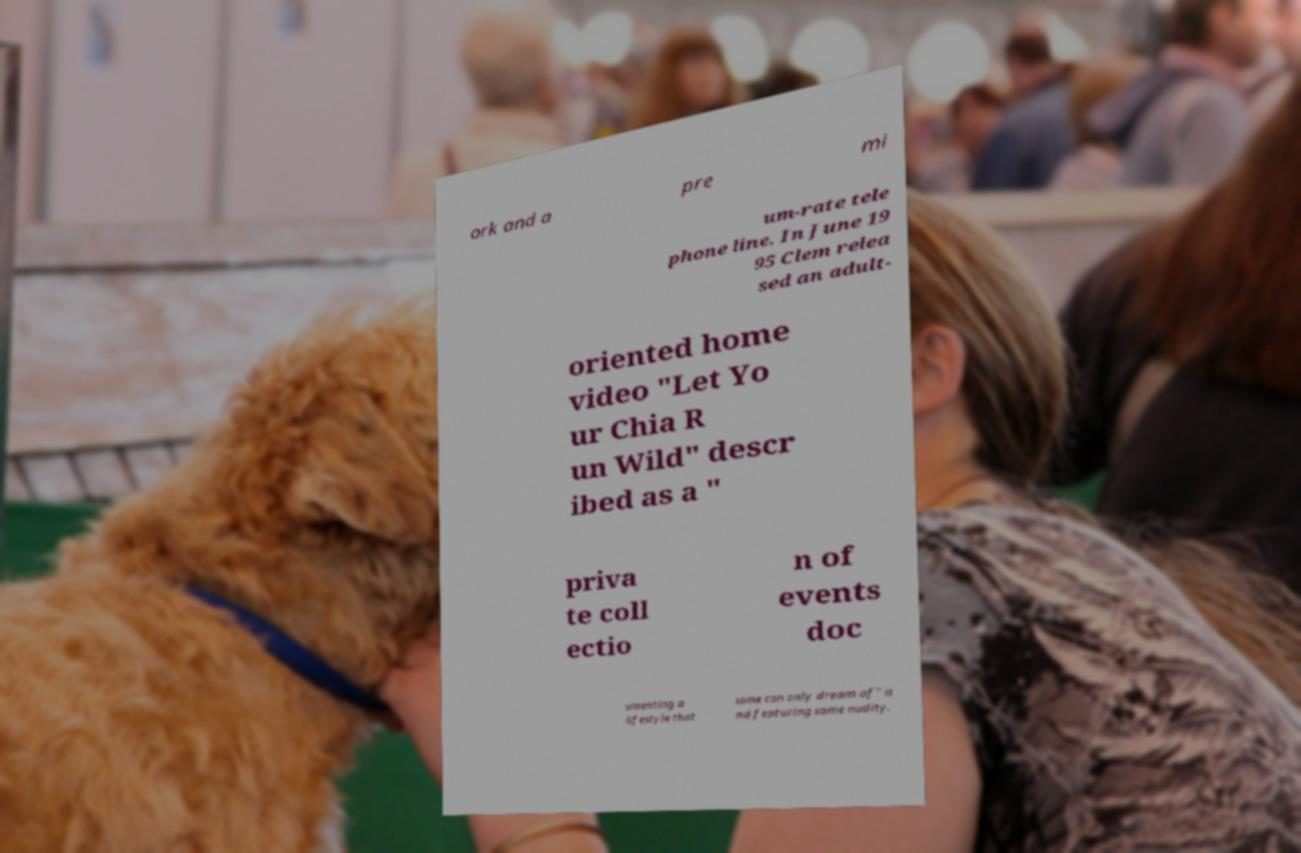Can you read and provide the text displayed in the image?This photo seems to have some interesting text. Can you extract and type it out for me? ork and a pre mi um-rate tele phone line. In June 19 95 Clem relea sed an adult- oriented home video "Let Yo ur Chia R un Wild" descr ibed as a " priva te coll ectio n of events doc umenting a lifestyle that some can only dream of" a nd featuring some nudity. 